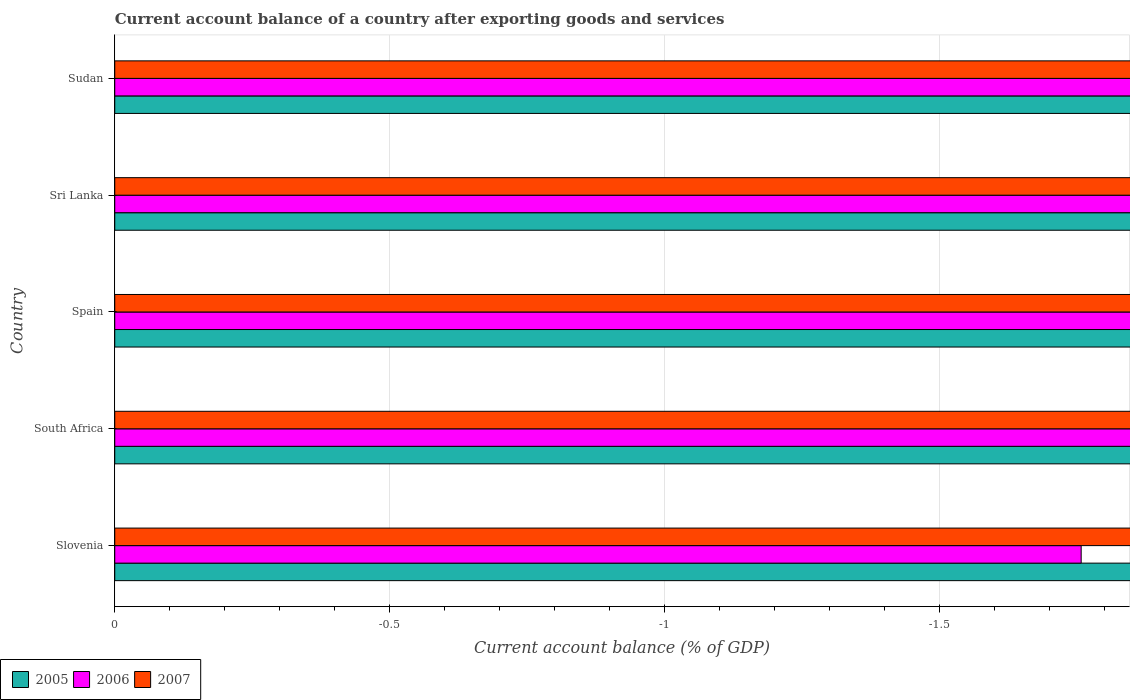Are the number of bars per tick equal to the number of legend labels?
Offer a very short reply. No. How many bars are there on the 1st tick from the top?
Offer a terse response. 0. How many bars are there on the 3rd tick from the bottom?
Your response must be concise. 0. What is the label of the 2nd group of bars from the top?
Provide a short and direct response. Sri Lanka. Across all countries, what is the minimum account balance in 2005?
Make the answer very short. 0. In how many countries, is the account balance in 2006 greater than the average account balance in 2006 taken over all countries?
Ensure brevity in your answer.  0. Are all the bars in the graph horizontal?
Offer a terse response. Yes. Does the graph contain any zero values?
Your answer should be compact. Yes. Does the graph contain grids?
Your response must be concise. Yes. What is the title of the graph?
Your answer should be very brief. Current account balance of a country after exporting goods and services. What is the label or title of the X-axis?
Your answer should be compact. Current account balance (% of GDP). What is the label or title of the Y-axis?
Your response must be concise. Country. What is the Current account balance (% of GDP) of 2007 in Slovenia?
Your answer should be compact. 0. What is the Current account balance (% of GDP) in 2005 in Spain?
Provide a short and direct response. 0. What is the Current account balance (% of GDP) of 2006 in Spain?
Offer a terse response. 0. What is the Current account balance (% of GDP) in 2006 in Sri Lanka?
Make the answer very short. 0. What is the Current account balance (% of GDP) of 2005 in Sudan?
Your response must be concise. 0. What is the total Current account balance (% of GDP) in 2006 in the graph?
Provide a short and direct response. 0. What is the total Current account balance (% of GDP) in 2007 in the graph?
Keep it short and to the point. 0. What is the average Current account balance (% of GDP) in 2005 per country?
Give a very brief answer. 0. 